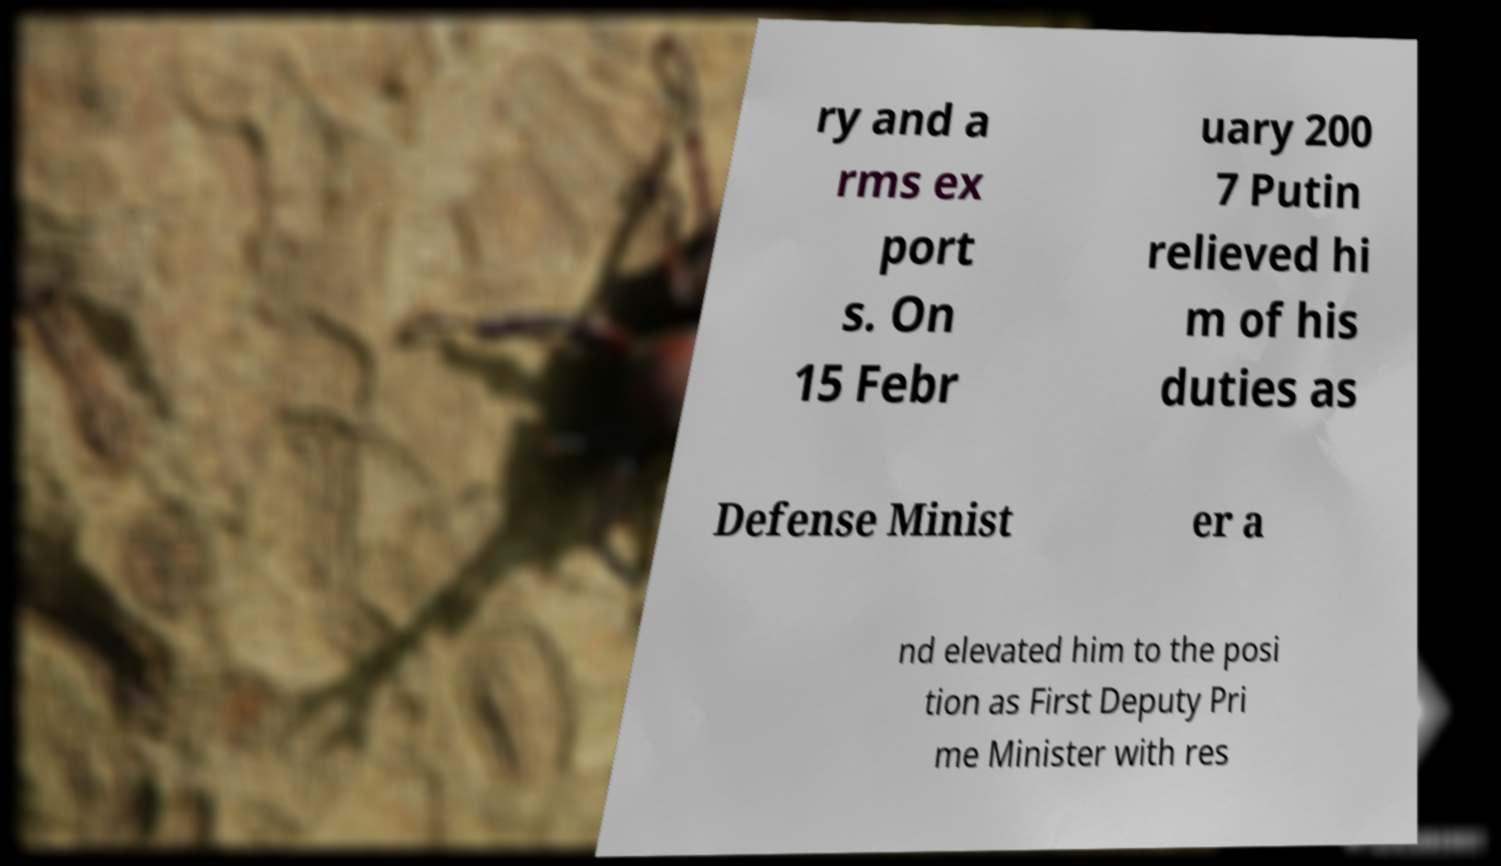Can you accurately transcribe the text from the provided image for me? ry and a rms ex port s. On 15 Febr uary 200 7 Putin relieved hi m of his duties as Defense Minist er a nd elevated him to the posi tion as First Deputy Pri me Minister with res 